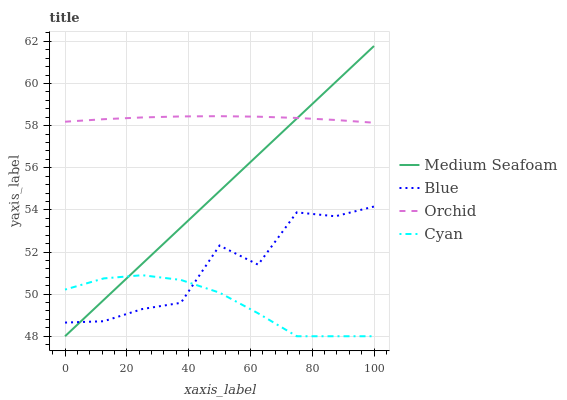Does Cyan have the minimum area under the curve?
Answer yes or no. Yes. Does Orchid have the maximum area under the curve?
Answer yes or no. Yes. Does Medium Seafoam have the minimum area under the curve?
Answer yes or no. No. Does Medium Seafoam have the maximum area under the curve?
Answer yes or no. No. Is Medium Seafoam the smoothest?
Answer yes or no. Yes. Is Blue the roughest?
Answer yes or no. Yes. Is Cyan the smoothest?
Answer yes or no. No. Is Cyan the roughest?
Answer yes or no. No. Does Cyan have the lowest value?
Answer yes or no. Yes. Does Orchid have the lowest value?
Answer yes or no. No. Does Medium Seafoam have the highest value?
Answer yes or no. Yes. Does Cyan have the highest value?
Answer yes or no. No. Is Blue less than Orchid?
Answer yes or no. Yes. Is Orchid greater than Blue?
Answer yes or no. Yes. Does Medium Seafoam intersect Cyan?
Answer yes or no. Yes. Is Medium Seafoam less than Cyan?
Answer yes or no. No. Is Medium Seafoam greater than Cyan?
Answer yes or no. No. Does Blue intersect Orchid?
Answer yes or no. No. 